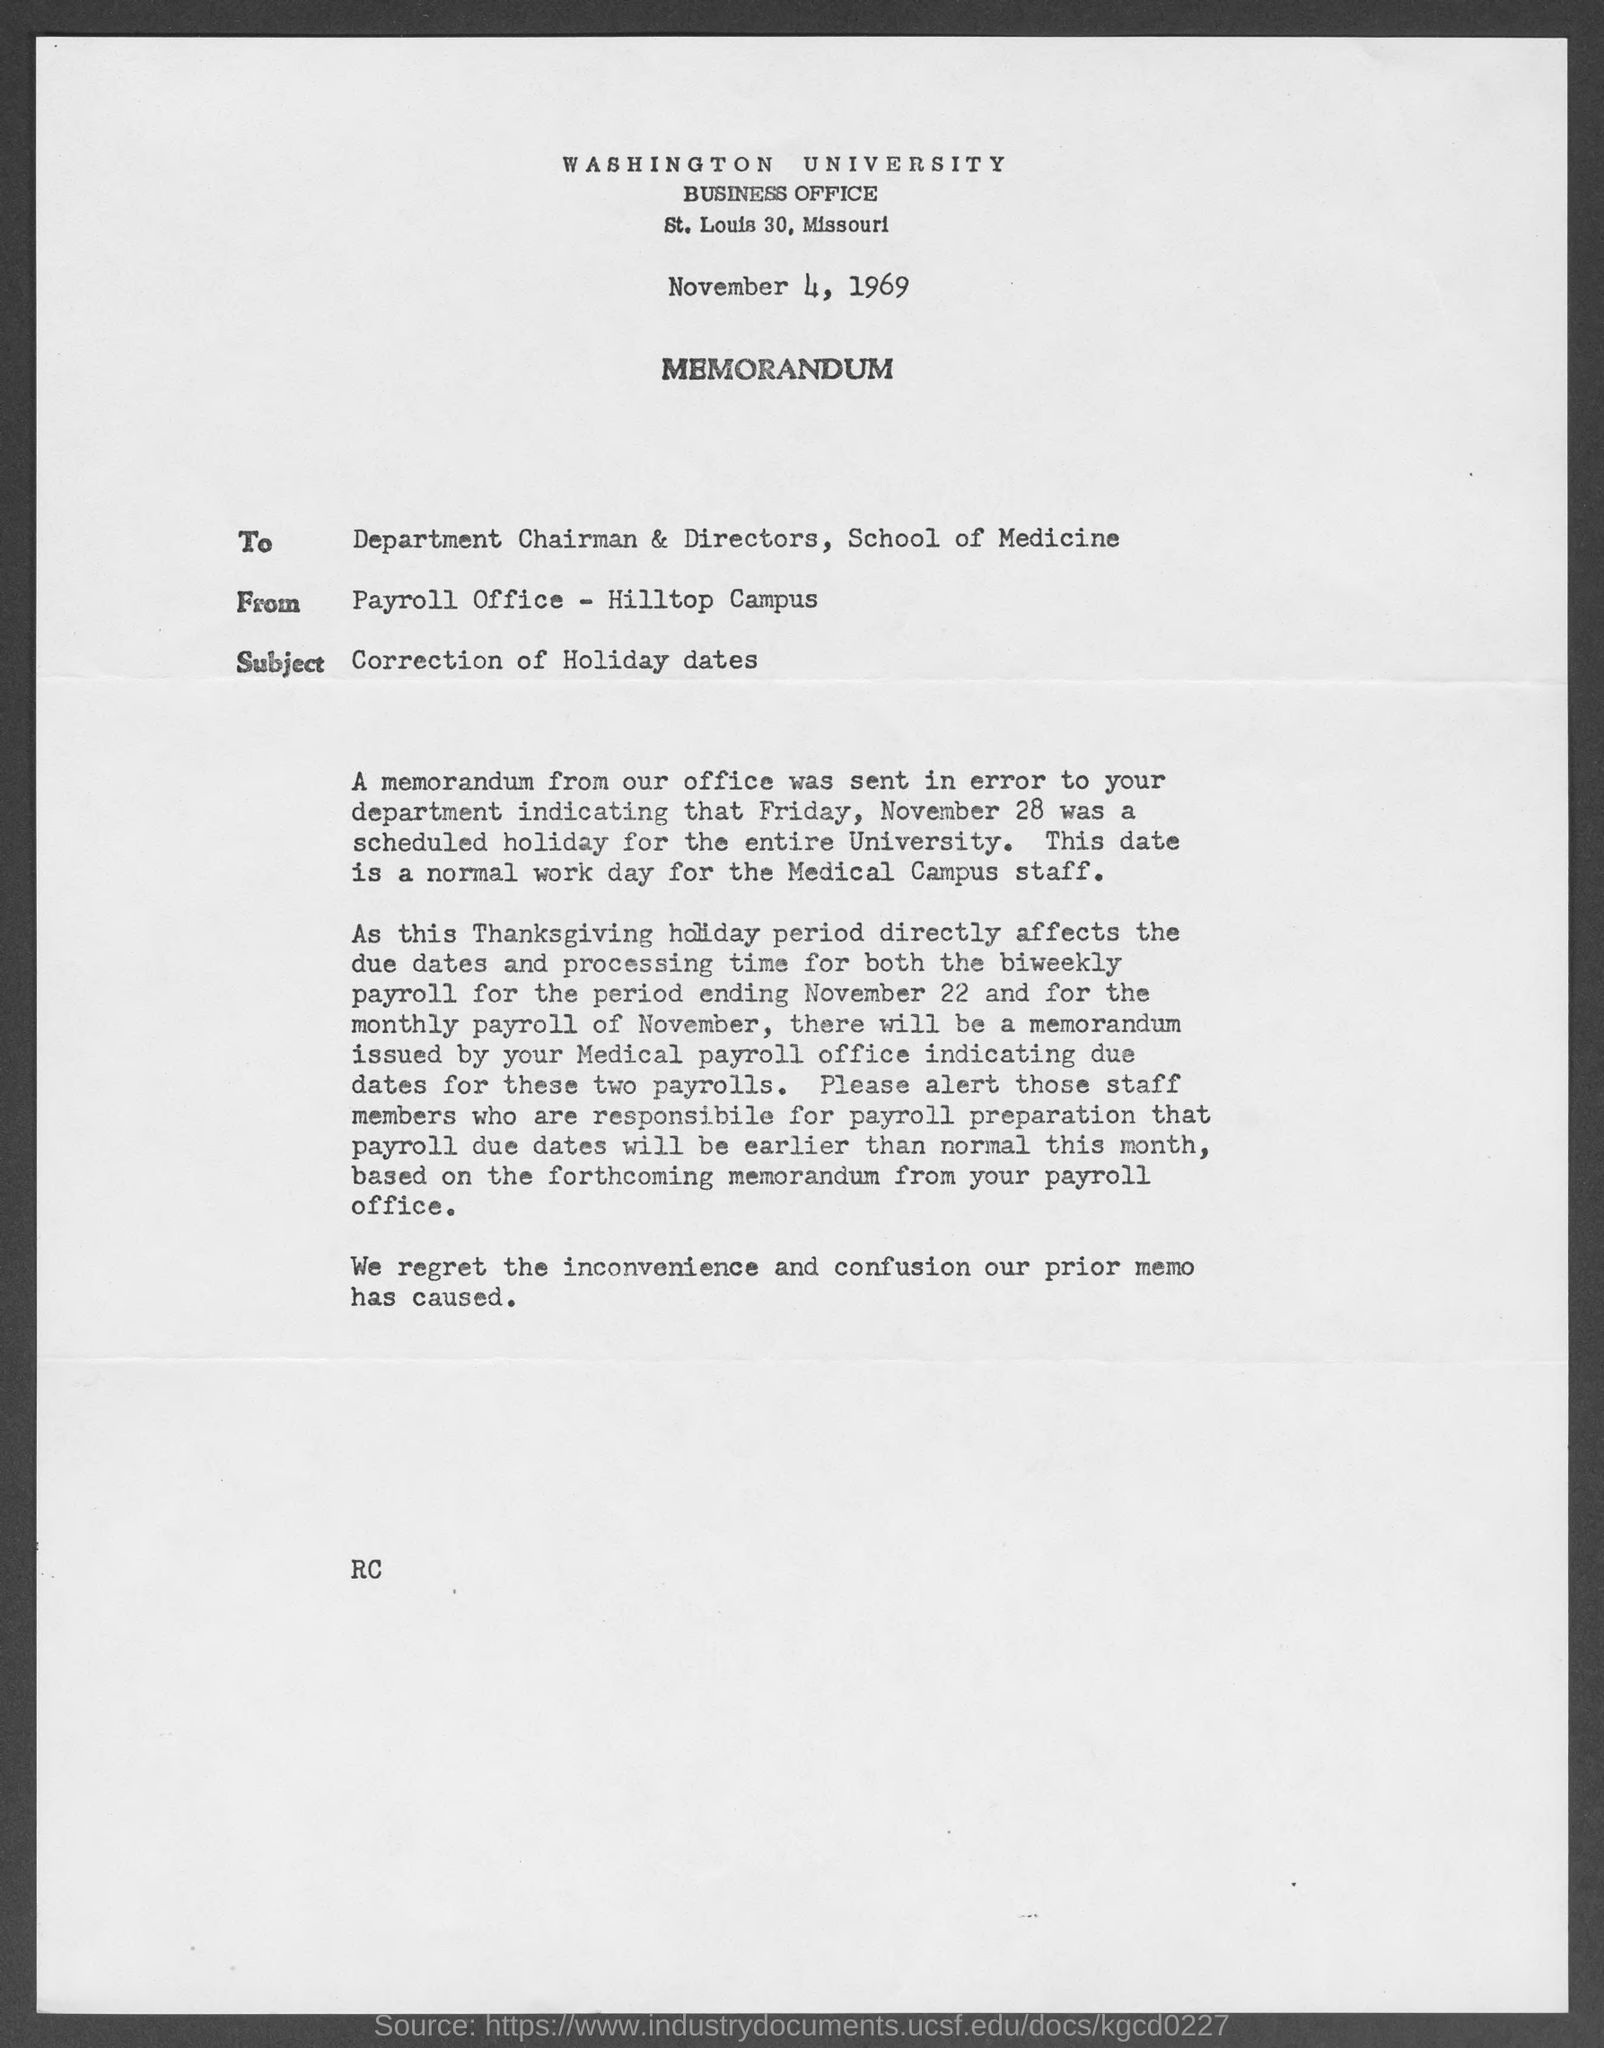What is from address in memorandum ?
Offer a very short reply. Payroll office- Hilltop Campus. What is the subject of memorandum ?
Make the answer very short. Correction of Holiday dates. 